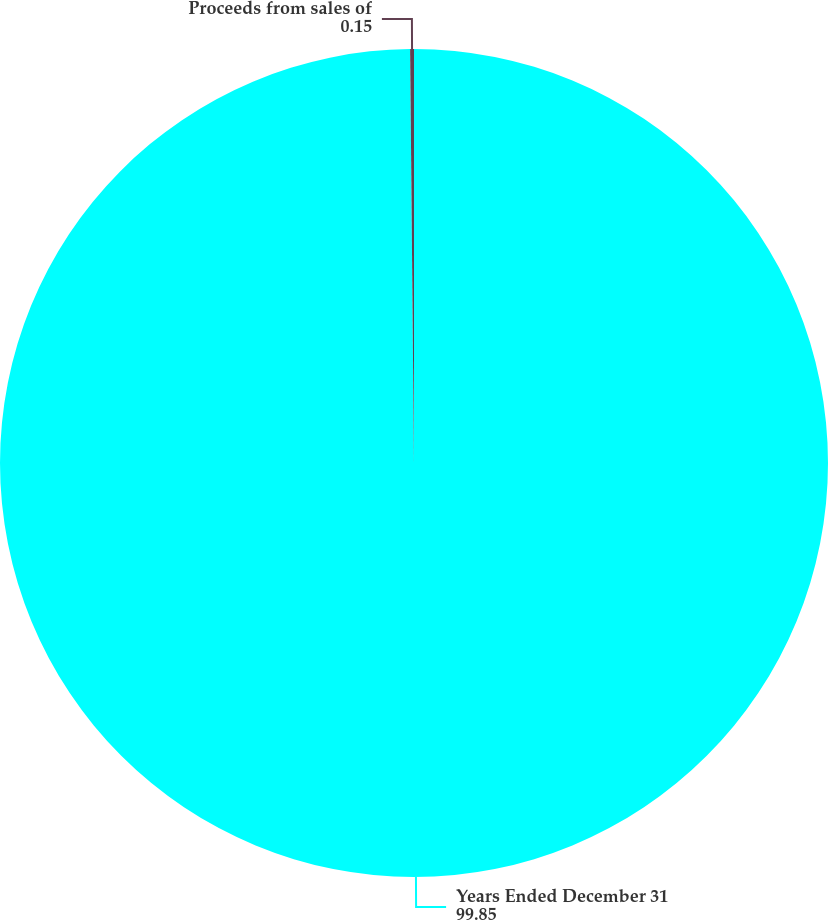Convert chart. <chart><loc_0><loc_0><loc_500><loc_500><pie_chart><fcel>Years Ended December 31<fcel>Proceeds from sales of<nl><fcel>99.85%<fcel>0.15%<nl></chart> 